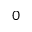Convert formula to latex. <formula><loc_0><loc_0><loc_500><loc_500>0</formula> 